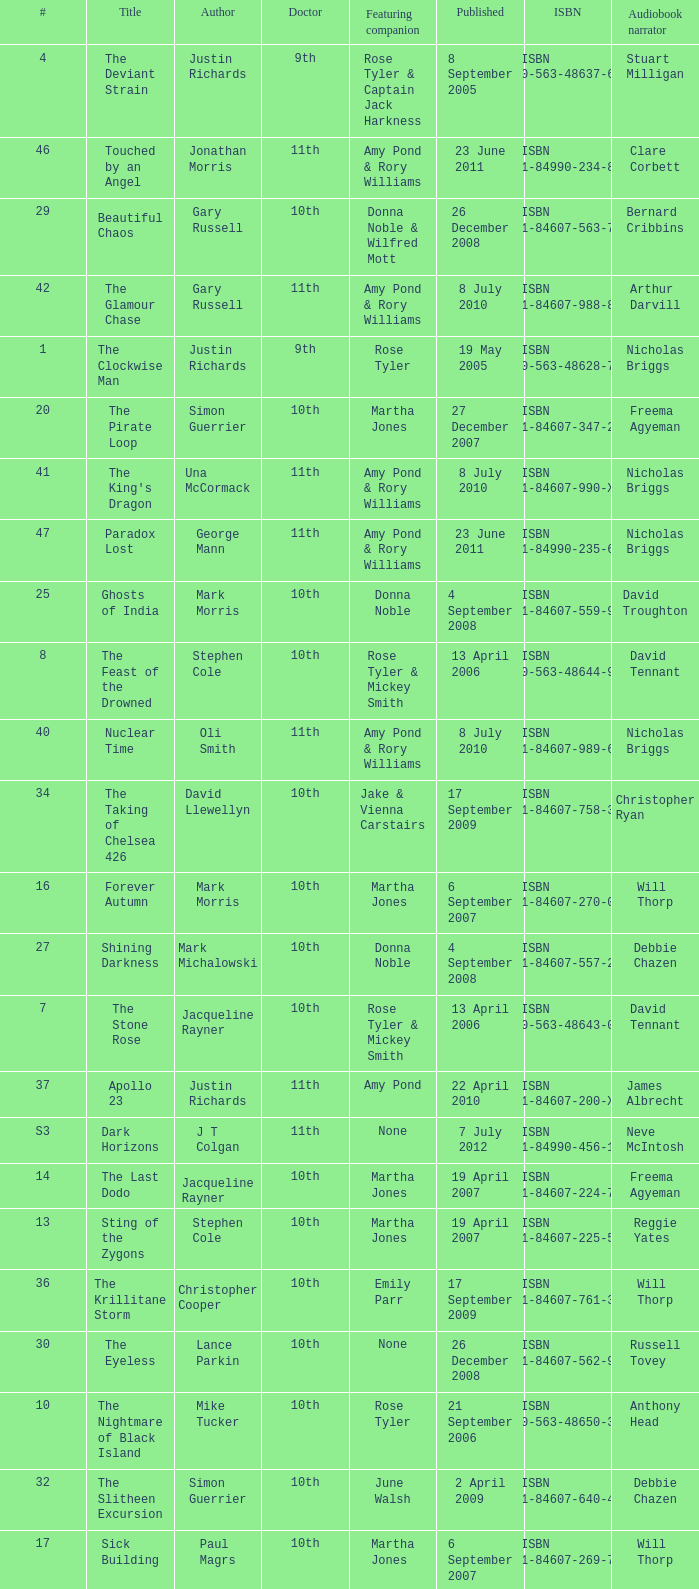What is the title of book number 8? The Feast of the Drowned. 